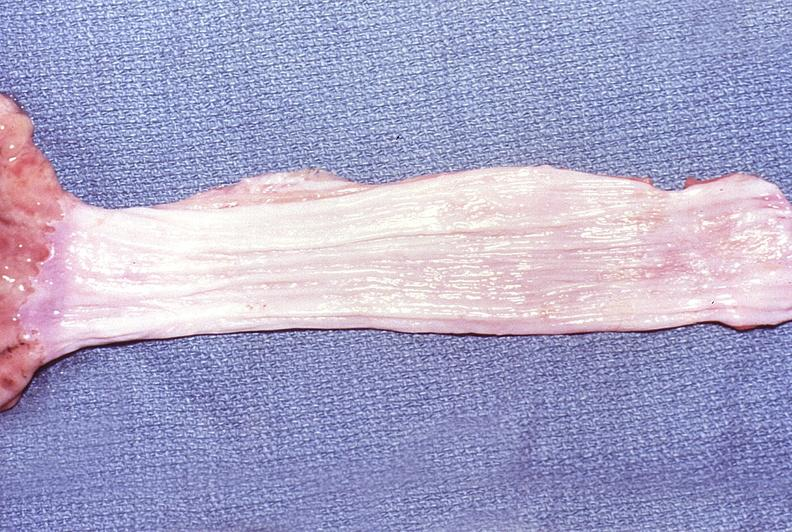does granulosa cell tumor show normal esophagus?
Answer the question using a single word or phrase. No 